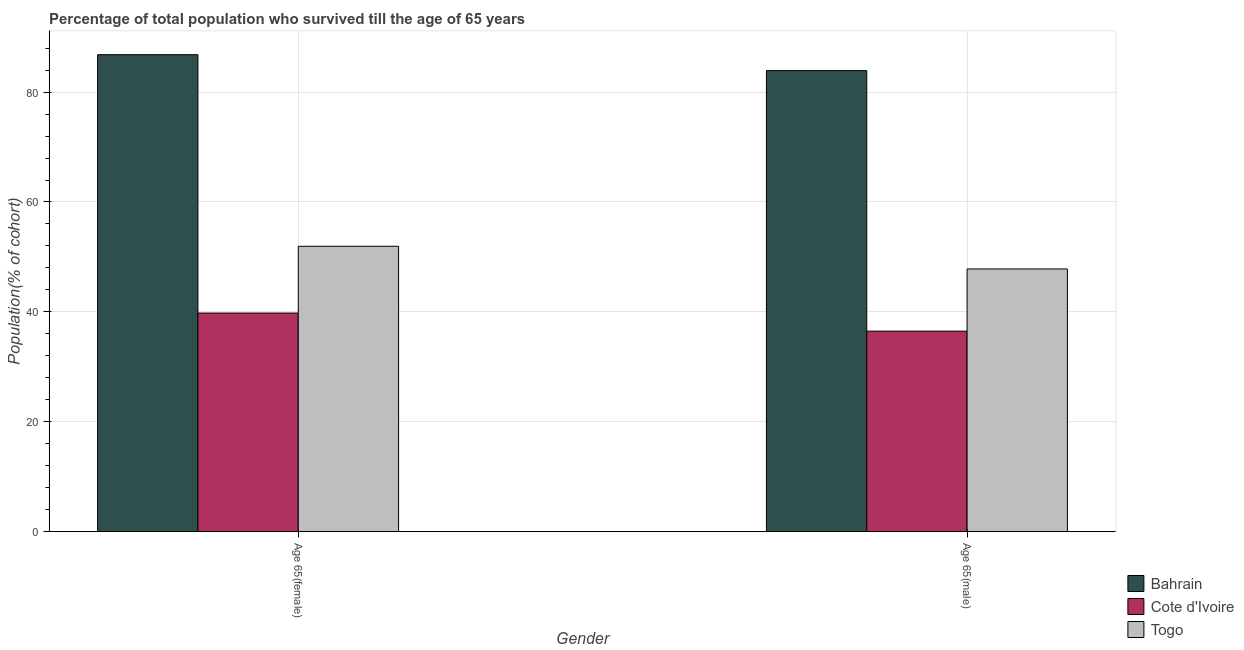Are the number of bars per tick equal to the number of legend labels?
Provide a short and direct response. Yes. How many bars are there on the 2nd tick from the left?
Your answer should be very brief. 3. How many bars are there on the 2nd tick from the right?
Provide a succinct answer. 3. What is the label of the 1st group of bars from the left?
Provide a succinct answer. Age 65(female). What is the percentage of male population who survived till age of 65 in Bahrain?
Your answer should be very brief. 83.91. Across all countries, what is the maximum percentage of female population who survived till age of 65?
Ensure brevity in your answer.  86.81. Across all countries, what is the minimum percentage of male population who survived till age of 65?
Your answer should be compact. 36.5. In which country was the percentage of male population who survived till age of 65 maximum?
Your answer should be compact. Bahrain. In which country was the percentage of female population who survived till age of 65 minimum?
Your response must be concise. Cote d'Ivoire. What is the total percentage of female population who survived till age of 65 in the graph?
Your answer should be very brief. 178.54. What is the difference between the percentage of male population who survived till age of 65 in Bahrain and that in Cote d'Ivoire?
Keep it short and to the point. 47.41. What is the difference between the percentage of male population who survived till age of 65 in Bahrain and the percentage of female population who survived till age of 65 in Togo?
Your answer should be very brief. 31.97. What is the average percentage of female population who survived till age of 65 per country?
Your response must be concise. 59.51. What is the difference between the percentage of male population who survived till age of 65 and percentage of female population who survived till age of 65 in Bahrain?
Your answer should be very brief. -2.9. In how many countries, is the percentage of female population who survived till age of 65 greater than 52 %?
Ensure brevity in your answer.  1. What is the ratio of the percentage of male population who survived till age of 65 in Cote d'Ivoire to that in Togo?
Make the answer very short. 0.76. Is the percentage of male population who survived till age of 65 in Cote d'Ivoire less than that in Togo?
Offer a terse response. Yes. In how many countries, is the percentage of female population who survived till age of 65 greater than the average percentage of female population who survived till age of 65 taken over all countries?
Your answer should be very brief. 1. What does the 1st bar from the left in Age 65(female) represents?
Make the answer very short. Bahrain. What does the 2nd bar from the right in Age 65(male) represents?
Provide a short and direct response. Cote d'Ivoire. How many countries are there in the graph?
Offer a very short reply. 3. Where does the legend appear in the graph?
Offer a terse response. Bottom right. What is the title of the graph?
Keep it short and to the point. Percentage of total population who survived till the age of 65 years. Does "Senegal" appear as one of the legend labels in the graph?
Your answer should be compact. No. What is the label or title of the X-axis?
Offer a very short reply. Gender. What is the label or title of the Y-axis?
Give a very brief answer. Population(% of cohort). What is the Population(% of cohort) in Bahrain in Age 65(female)?
Your answer should be compact. 86.81. What is the Population(% of cohort) in Cote d'Ivoire in Age 65(female)?
Ensure brevity in your answer.  39.79. What is the Population(% of cohort) of Togo in Age 65(female)?
Your response must be concise. 51.94. What is the Population(% of cohort) in Bahrain in Age 65(male)?
Give a very brief answer. 83.91. What is the Population(% of cohort) of Cote d'Ivoire in Age 65(male)?
Make the answer very short. 36.5. What is the Population(% of cohort) in Togo in Age 65(male)?
Ensure brevity in your answer.  47.82. Across all Gender, what is the maximum Population(% of cohort) of Bahrain?
Provide a succinct answer. 86.81. Across all Gender, what is the maximum Population(% of cohort) in Cote d'Ivoire?
Make the answer very short. 39.79. Across all Gender, what is the maximum Population(% of cohort) in Togo?
Your answer should be compact. 51.94. Across all Gender, what is the minimum Population(% of cohort) in Bahrain?
Provide a succinct answer. 83.91. Across all Gender, what is the minimum Population(% of cohort) of Cote d'Ivoire?
Your answer should be very brief. 36.5. Across all Gender, what is the minimum Population(% of cohort) of Togo?
Your answer should be compact. 47.82. What is the total Population(% of cohort) of Bahrain in the graph?
Your response must be concise. 170.72. What is the total Population(% of cohort) of Cote d'Ivoire in the graph?
Offer a very short reply. 76.29. What is the total Population(% of cohort) in Togo in the graph?
Ensure brevity in your answer.  99.76. What is the difference between the Population(% of cohort) of Bahrain in Age 65(female) and that in Age 65(male)?
Make the answer very short. 2.9. What is the difference between the Population(% of cohort) of Cote d'Ivoire in Age 65(female) and that in Age 65(male)?
Your answer should be compact. 3.29. What is the difference between the Population(% of cohort) in Togo in Age 65(female) and that in Age 65(male)?
Keep it short and to the point. 4.13. What is the difference between the Population(% of cohort) of Bahrain in Age 65(female) and the Population(% of cohort) of Cote d'Ivoire in Age 65(male)?
Give a very brief answer. 50.31. What is the difference between the Population(% of cohort) of Bahrain in Age 65(female) and the Population(% of cohort) of Togo in Age 65(male)?
Give a very brief answer. 38.99. What is the difference between the Population(% of cohort) of Cote d'Ivoire in Age 65(female) and the Population(% of cohort) of Togo in Age 65(male)?
Provide a succinct answer. -8.02. What is the average Population(% of cohort) in Bahrain per Gender?
Your answer should be compact. 85.36. What is the average Population(% of cohort) of Cote d'Ivoire per Gender?
Your answer should be compact. 38.15. What is the average Population(% of cohort) in Togo per Gender?
Keep it short and to the point. 49.88. What is the difference between the Population(% of cohort) of Bahrain and Population(% of cohort) of Cote d'Ivoire in Age 65(female)?
Keep it short and to the point. 47.02. What is the difference between the Population(% of cohort) in Bahrain and Population(% of cohort) in Togo in Age 65(female)?
Your response must be concise. 34.87. What is the difference between the Population(% of cohort) of Cote d'Ivoire and Population(% of cohort) of Togo in Age 65(female)?
Offer a very short reply. -12.15. What is the difference between the Population(% of cohort) in Bahrain and Population(% of cohort) in Cote d'Ivoire in Age 65(male)?
Provide a short and direct response. 47.41. What is the difference between the Population(% of cohort) in Bahrain and Population(% of cohort) in Togo in Age 65(male)?
Your response must be concise. 36.09. What is the difference between the Population(% of cohort) of Cote d'Ivoire and Population(% of cohort) of Togo in Age 65(male)?
Your response must be concise. -11.32. What is the ratio of the Population(% of cohort) in Bahrain in Age 65(female) to that in Age 65(male)?
Offer a terse response. 1.03. What is the ratio of the Population(% of cohort) of Cote d'Ivoire in Age 65(female) to that in Age 65(male)?
Make the answer very short. 1.09. What is the ratio of the Population(% of cohort) in Togo in Age 65(female) to that in Age 65(male)?
Your response must be concise. 1.09. What is the difference between the highest and the second highest Population(% of cohort) of Bahrain?
Offer a very short reply. 2.9. What is the difference between the highest and the second highest Population(% of cohort) in Cote d'Ivoire?
Provide a short and direct response. 3.29. What is the difference between the highest and the second highest Population(% of cohort) of Togo?
Provide a succinct answer. 4.13. What is the difference between the highest and the lowest Population(% of cohort) of Bahrain?
Give a very brief answer. 2.9. What is the difference between the highest and the lowest Population(% of cohort) in Cote d'Ivoire?
Your answer should be very brief. 3.29. What is the difference between the highest and the lowest Population(% of cohort) of Togo?
Offer a very short reply. 4.13. 